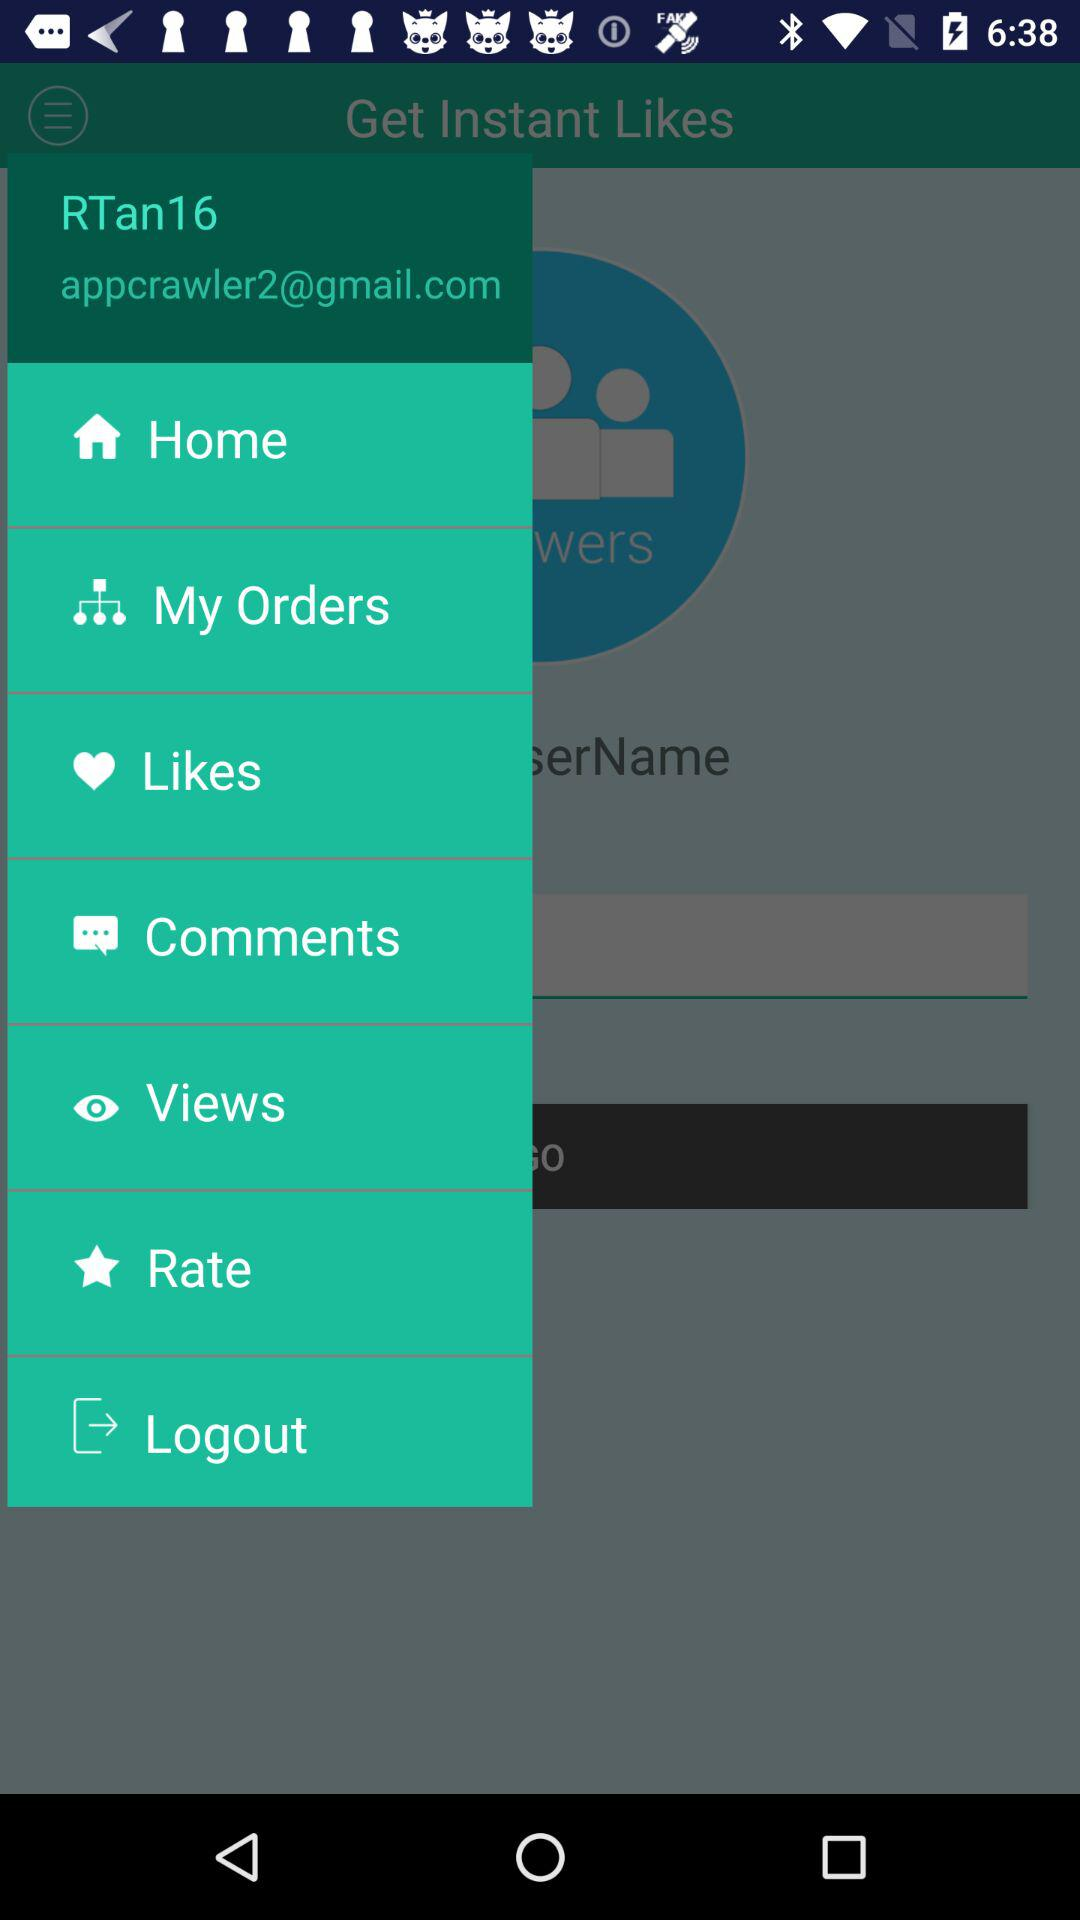What is the Gmail account address? The Gmail account address is appcrawler2@gmail.com. 